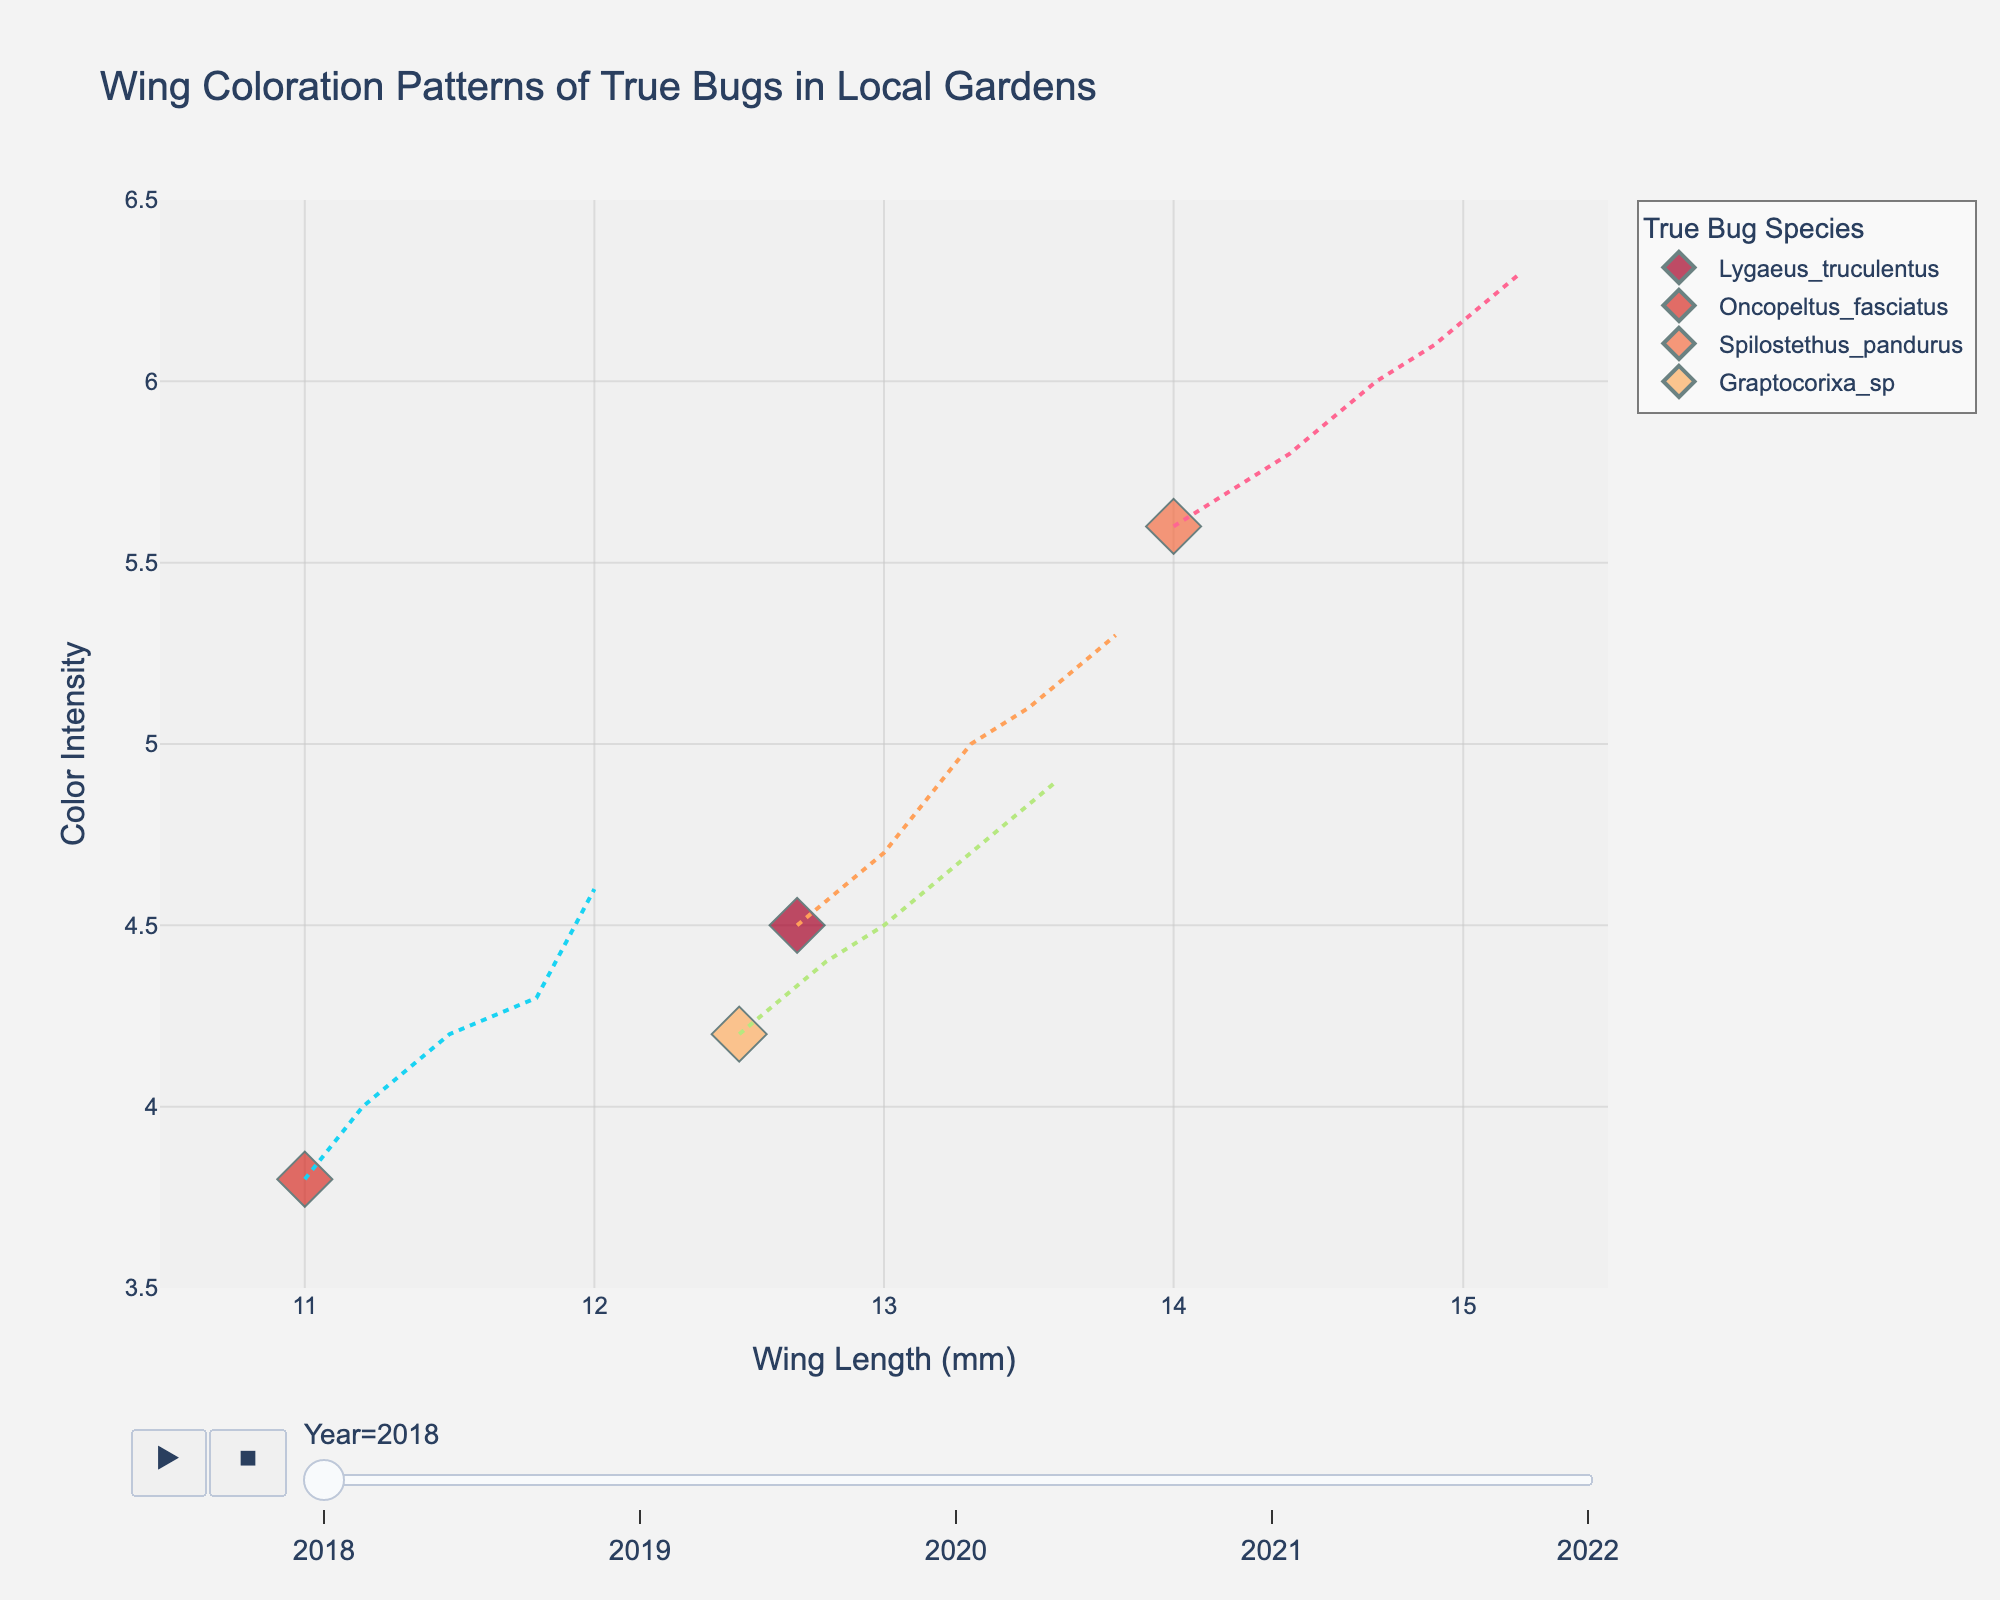What is the title of the plot? The title of a plot will usually be displayed at the top and summarizes the key information presented.
Answer: Wing Coloration Patterns of True Bugs in Local Gardens What is the color intensity of Lygaeus truculentus in 2020? To find this, look for the wing length that corresponds to Lygaeus truculentus in the year 2020 and check the y-axis value.
Answer: 5.0 How many species are represented in the plot? Each species is represented by a different color, and their names are listed in the legend. Counting these unique names gives the answer.
Answer: 4 Which species has the highest wing length in 2022? Examine the data points for the year 2022 and check the x-axis values. The species with the highest wing length will be the one farthest to the right.
Answer: Spilostethus pandurus What is the trend of color intensity for Oncopeltus fasciatus over the years? Look at the series of data points corresponding to Oncopeltus fasciatus and check if the y-axis values are increasing, decreasing, or staying constant over the years.
Answer: Increasing Is there any species that shows a decreasing trend in color intensity? To determine this, examine the trend lines in the plot and look for any species whose dots are moving downward over the years.
Answer: No Which species shows the largest increase in wing length from 2018 to 2022? Calculate the difference in wing length for each species between the years 2018 and 2022, then identify which species has the largest increase.
Answer: Spilostethus pandurus Are any species' wing lengths overlapping in any year? Check if multiple species have data points at the same x-axis value (wing length) in the same year.
Answer: No Which species had the lowest color intensity in 2018 and what was the value? Look at the 2018 data points and find the lowest value on the y-axis, then identify the species.
Answer: Oncopeltus fasciatus, 3.8 